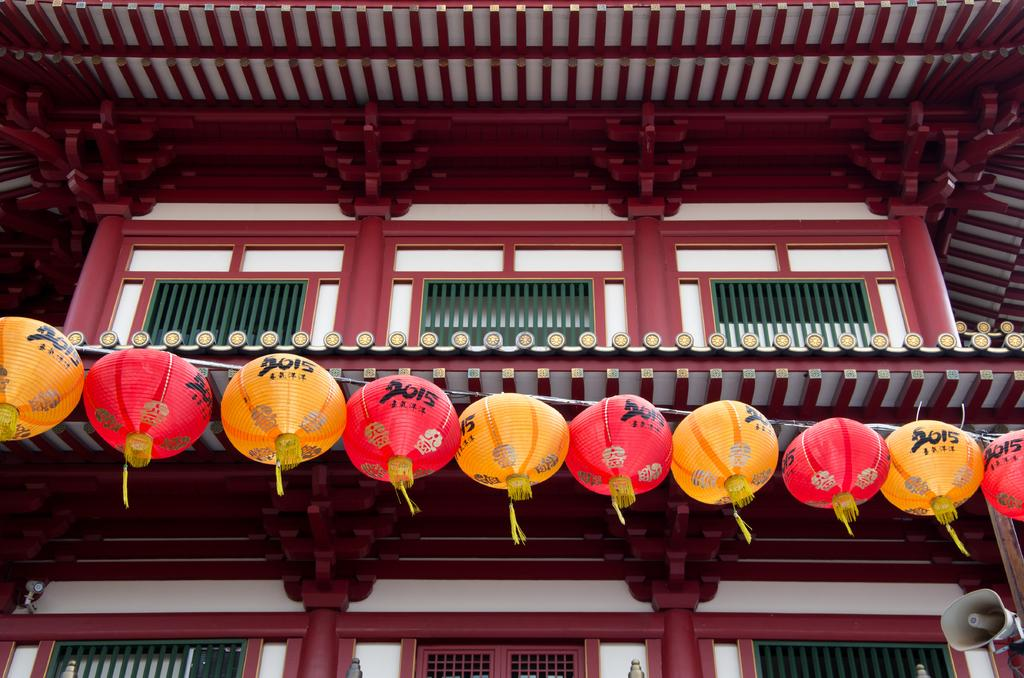Provide a one-sentence caption for the provided image. A line of orange and red lanterns signify that the year is 2015. 